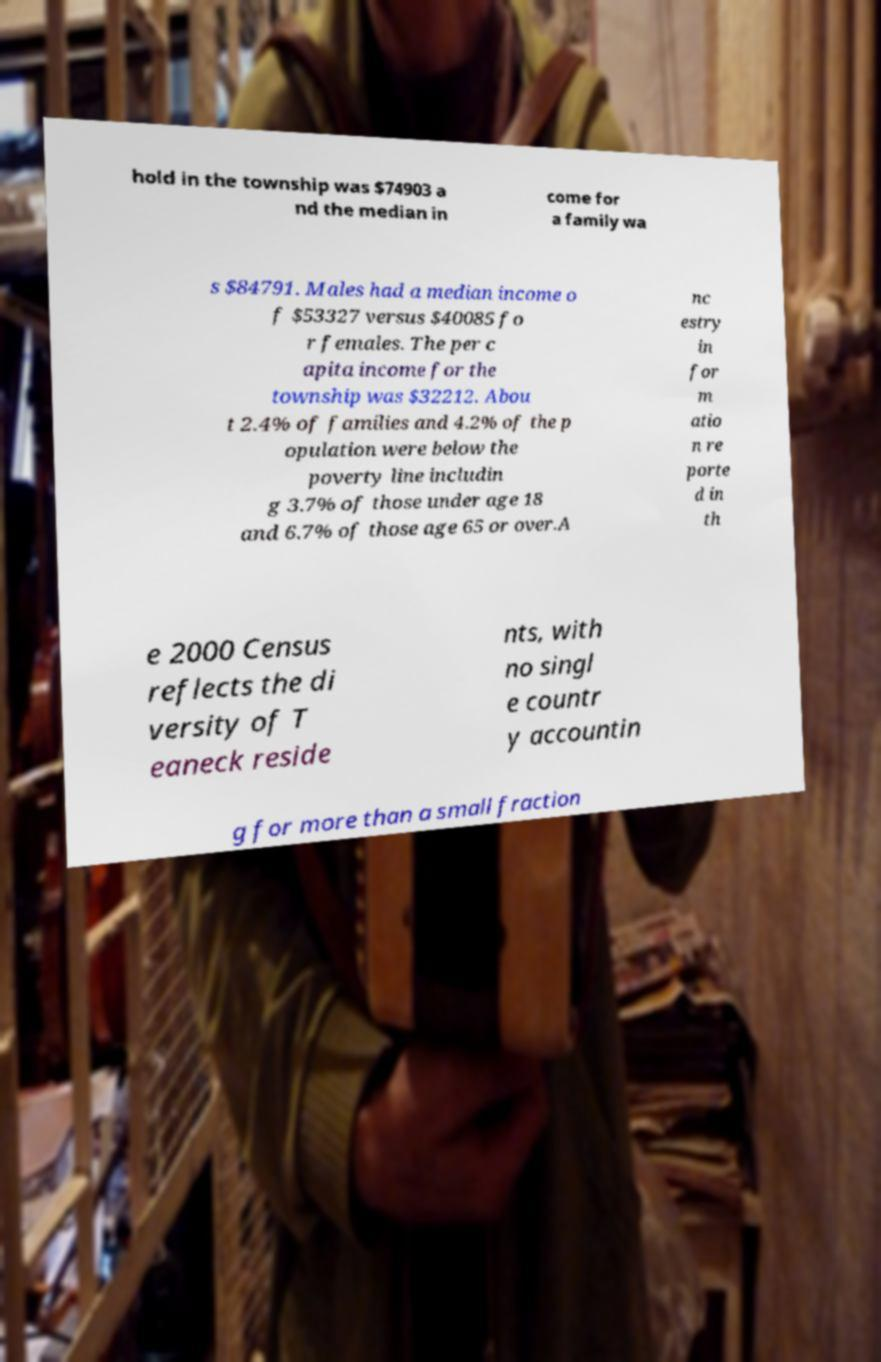Please identify and transcribe the text found in this image. hold in the township was $74903 a nd the median in come for a family wa s $84791. Males had a median income o f $53327 versus $40085 fo r females. The per c apita income for the township was $32212. Abou t 2.4% of families and 4.2% of the p opulation were below the poverty line includin g 3.7% of those under age 18 and 6.7% of those age 65 or over.A nc estry in for m atio n re porte d in th e 2000 Census reflects the di versity of T eaneck reside nts, with no singl e countr y accountin g for more than a small fraction 